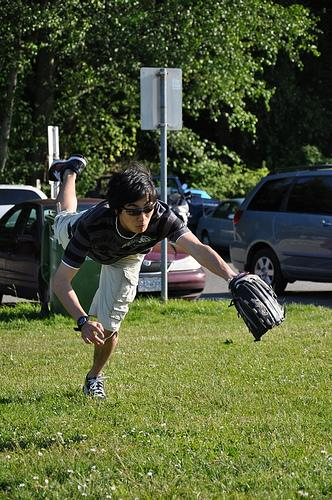What handedness does this person have? right 